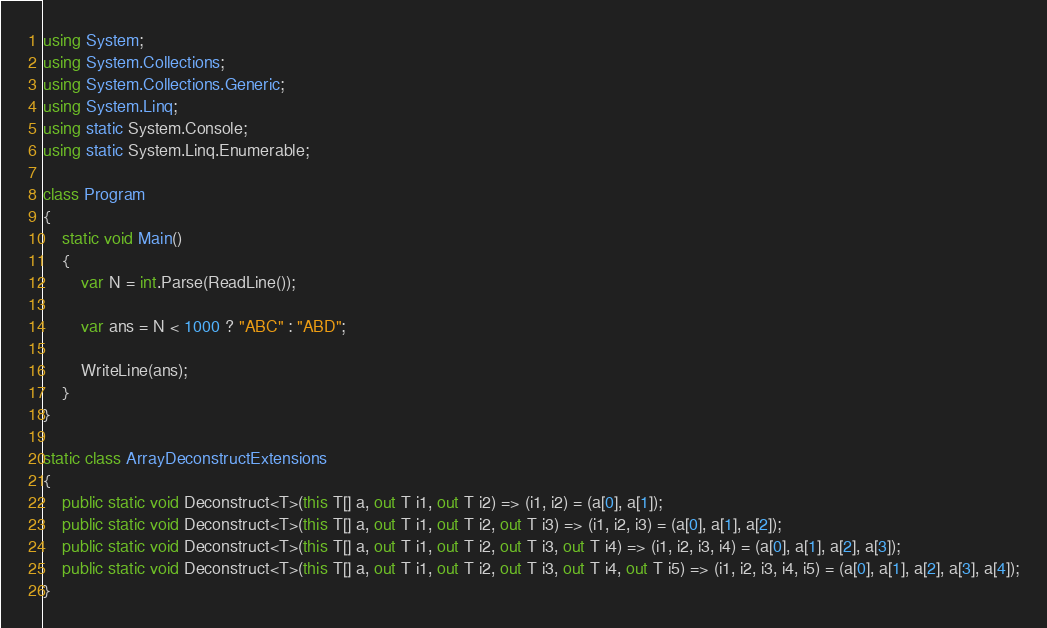Convert code to text. <code><loc_0><loc_0><loc_500><loc_500><_C#_>using System;
using System.Collections;
using System.Collections.Generic;
using System.Linq;
using static System.Console;
using static System.Linq.Enumerable;

class Program
{
    static void Main()
    {
        var N = int.Parse(ReadLine());

        var ans = N < 1000 ? "ABC" : "ABD";

        WriteLine(ans);
    }
}

static class ArrayDeconstructExtensions
{
    public static void Deconstruct<T>(this T[] a, out T i1, out T i2) => (i1, i2) = (a[0], a[1]);
    public static void Deconstruct<T>(this T[] a, out T i1, out T i2, out T i3) => (i1, i2, i3) = (a[0], a[1], a[2]);
    public static void Deconstruct<T>(this T[] a, out T i1, out T i2, out T i3, out T i4) => (i1, i2, i3, i4) = (a[0], a[1], a[2], a[3]);
    public static void Deconstruct<T>(this T[] a, out T i1, out T i2, out T i3, out T i4, out T i5) => (i1, i2, i3, i4, i5) = (a[0], a[1], a[2], a[3], a[4]);
}
</code> 